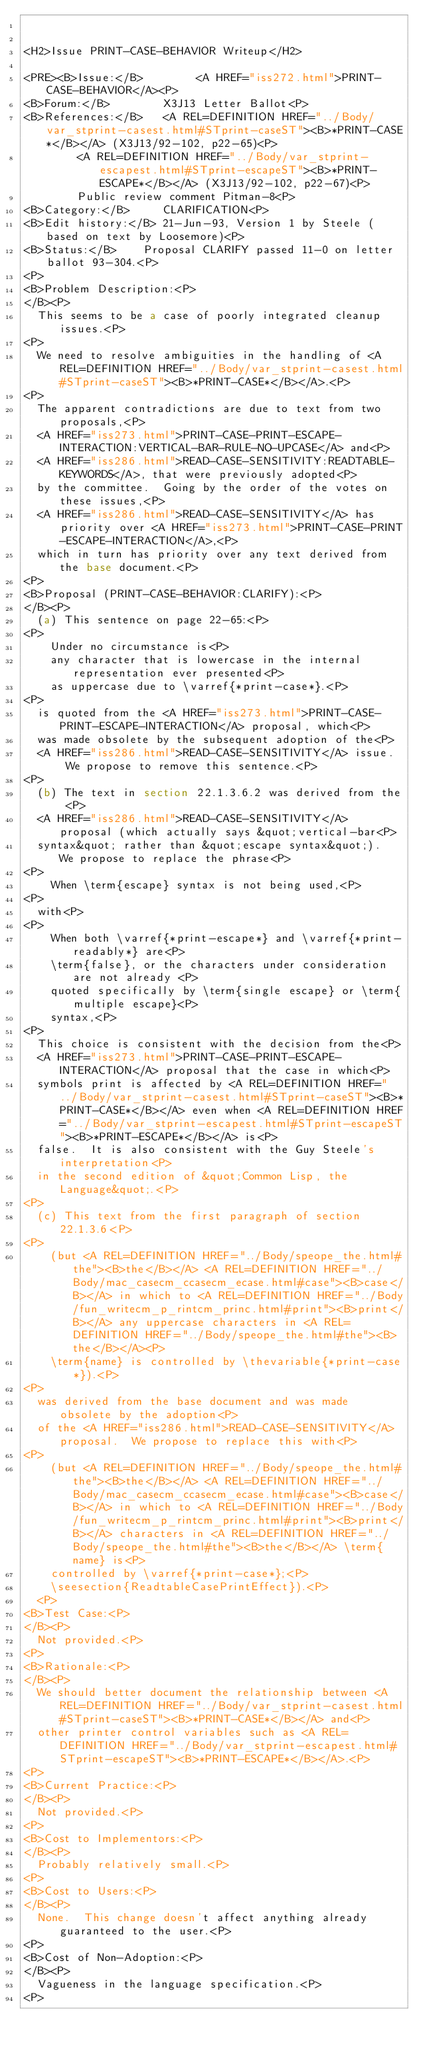<code> <loc_0><loc_0><loc_500><loc_500><_HTML_>

<H2>Issue PRINT-CASE-BEHAVIOR Writeup</H2>

<PRE><B>Issue:</B>        <A HREF="iss272.html">PRINT-CASE-BEHAVIOR</A><P>
<B>Forum:</B>        X3J13 Letter Ballot<P>
<B>References:</B>   <A REL=DEFINITION HREF="../Body/var_stprint-casest.html#STprint-caseST"><B>*PRINT-CASE*</B></A> (X3J13/92-102, p22-65)<P>
	      <A REL=DEFINITION HREF="../Body/var_stprint-escapest.html#STprint-escapeST"><B>*PRINT-ESCAPE*</B></A> (X3J13/92-102, p22-67)<P>
	      Public review comment Pitman-8<P>
<B>Category:</B>     CLARIFICATION<P>
<B>Edit history:</B> 21-Jun-93, Version 1 by Steele (based on text by Loosemore)<P>
<B>Status:</B>		Proposal CLARIFY passed 11-0 on letter ballot 93-304.<P>
<P>
<B>Problem Description:<P>
</B><P>
  This seems to be a case of poorly integrated cleanup issues.<P>
<P>
  We need to resolve ambiguities in the handling of <A REL=DEFINITION HREF="../Body/var_stprint-casest.html#STprint-caseST"><B>*PRINT-CASE*</B></A>.<P>
<P>
  The apparent contradictions are due to text from two proposals,<P>
  <A HREF="iss273.html">PRINT-CASE-PRINT-ESCAPE-INTERACTION:VERTICAL-BAR-RULE-NO-UPCASE</A> and<P>
  <A HREF="iss286.html">READ-CASE-SENSITIVITY:READTABLE-KEYWORDS</A>, that were previously adopted<P>
  by the committee.  Going by the order of the votes on these issues,<P>
  <A HREF="iss286.html">READ-CASE-SENSITIVITY</A> has priority over <A HREF="iss273.html">PRINT-CASE-PRINT-ESCAPE-INTERACTION</A>,<P>
  which in turn has priority over any text derived from the base document.<P>
<P>
<B>Proposal (PRINT-CASE-BEHAVIOR:CLARIFY):<P>
</B><P>
  (a) This sentence on page 22-65:<P>
<P>
    Under no circumstance is<P>
    any character that is lowercase in the internal representation ever presented<P>
    as uppercase due to \varref{*print-case*}.<P>
<P>
  is quoted from the <A HREF="iss273.html">PRINT-CASE-PRINT-ESCAPE-INTERACTION</A> proposal, which<P>
  was made obsolete by the subsequent adoption of the<P>
  <A HREF="iss286.html">READ-CASE-SENSITIVITY</A> issue.  We propose to remove this sentence.<P>
<P>
  (b) The text in section 22.1.3.6.2 was derived from the <P>
  <A HREF="iss286.html">READ-CASE-SENSITIVITY</A> proposal (which actually says &quot;vertical-bar<P>
  syntax&quot; rather than &quot;escape syntax&quot;).  We propose to replace the phrase<P>
<P>
    When \term{escape} syntax is not being used,<P>
<P>
  with<P>
<P>
    When both \varref{*print-escape*} and \varref{*print-readably*} are<P>
    \term{false}, or the characters under consideration are not already <P>
    quoted specifically by \term{single escape} or \term{multiple escape}<P>
    syntax,<P>
<P>
  This choice is consistent with the decision from the<P>
  <A HREF="iss273.html">PRINT-CASE-PRINT-ESCAPE-INTERACTION</A> proposal that the case in which<P>
  symbols print is affected by <A REL=DEFINITION HREF="../Body/var_stprint-casest.html#STprint-caseST"><B>*PRINT-CASE*</B></A> even when <A REL=DEFINITION HREF="../Body/var_stprint-escapest.html#STprint-escapeST"><B>*PRINT-ESCAPE*</B></A> is<P>
  false.  It is also consistent with the Guy Steele's interpretation<P>
  in the second edition of &quot;Common Lisp, the Language&quot;.<P>
<P>
  (c) This text from the first paragraph of section 22.1.3.6<P>
<P>
    (but <A REL=DEFINITION HREF="../Body/speope_the.html#the"><B>the</B></A> <A REL=DEFINITION HREF="../Body/mac_casecm_ccasecm_ecase.html#case"><B>case</B></A> in which to <A REL=DEFINITION HREF="../Body/fun_writecm_p_rintcm_princ.html#print"><B>print</B></A> any uppercase characters in <A REL=DEFINITION HREF="../Body/speope_the.html#the"><B>the</B></A><P>
    \term{name} is controlled by \thevariable{*print-case*}).<P>
<P>
  was derived from the base document and was made obsolete by the adoption<P>
  of the <A HREF="iss286.html">READ-CASE-SENSITIVITY</A> proposal.  We propose to replace this with<P>
<P>
    (but <A REL=DEFINITION HREF="../Body/speope_the.html#the"><B>the</B></A> <A REL=DEFINITION HREF="../Body/mac_casecm_ccasecm_ecase.html#case"><B>case</B></A> in which to <A REL=DEFINITION HREF="../Body/fun_writecm_p_rintcm_princ.html#print"><B>print</B></A> characters in <A REL=DEFINITION HREF="../Body/speope_the.html#the"><B>the</B></A> \term{name} is<P>
    controlled by \varref{*print-case*};<P>
    \seesection{ReadtableCasePrintEffect}).<P>
  <P>
<B>Test Case:<P>
</B><P>
  Not provided.<P>
<P>
<B>Rationale:<P>
</B><P>
  We should better document the relationship between <A REL=DEFINITION HREF="../Body/var_stprint-casest.html#STprint-caseST"><B>*PRINT-CASE*</B></A> and<P>
  other printer control variables such as <A REL=DEFINITION HREF="../Body/var_stprint-escapest.html#STprint-escapeST"><B>*PRINT-ESCAPE*</B></A>.<P>
<P>
<B>Current Practice:<P>
</B><P>
  Not provided.<P>
<P>
<B>Cost to Implementors:<P>
</B><P>
  Probably relatively small.<P>
<P>
<B>Cost to Users:<P>
</B><P>
  None.  This change doesn't affect anything already guaranteed to the user.<P>
<P>
<B>Cost of Non-Adoption:<P>
</B><P>
  Vagueness in the language specification.<P>
<P></code> 